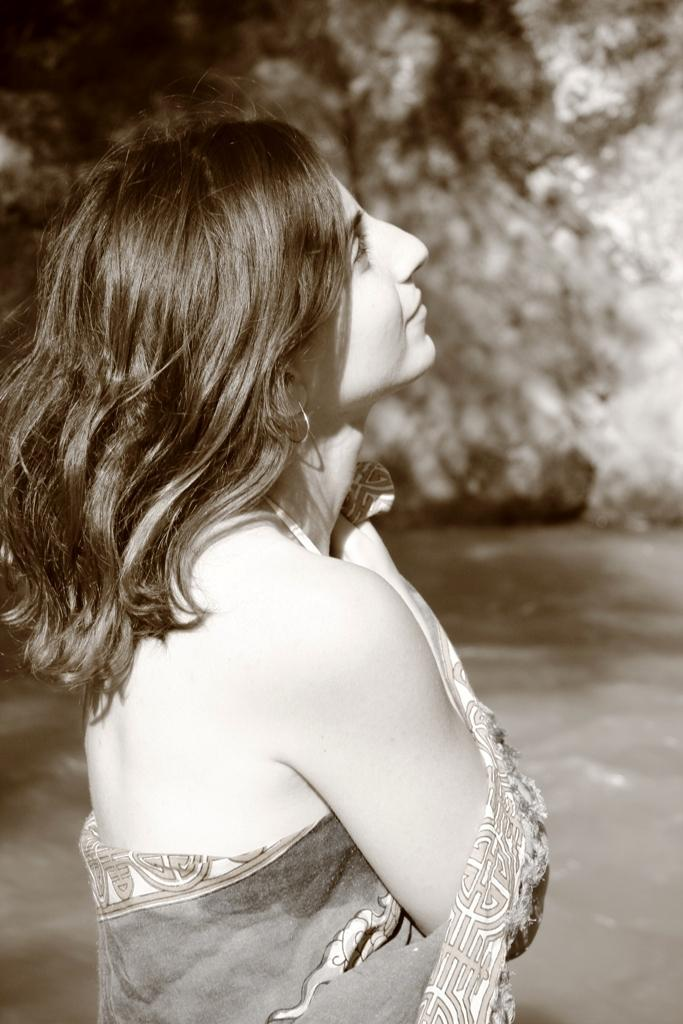What is the color scheme of the image? The image is black and white. Can you describe the main subject in the image? There is a lady in the image. What can be seen in the background of the image? The background of the image contains water. How is the background of the image depicted? The background is blurred. What type of brush is being used by the lady in the image? There is no brush visible in the image, as it is a black and white image of a lady with a blurred water background. 